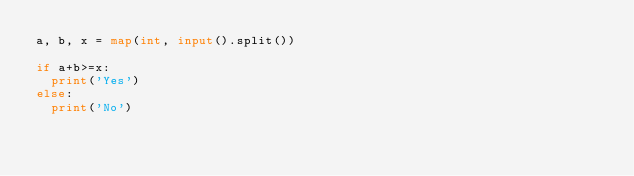Convert code to text. <code><loc_0><loc_0><loc_500><loc_500><_Python_>a, b, x = map(int, input().split())

if a+b>=x:
  print('Yes')
else:
  print('No')</code> 